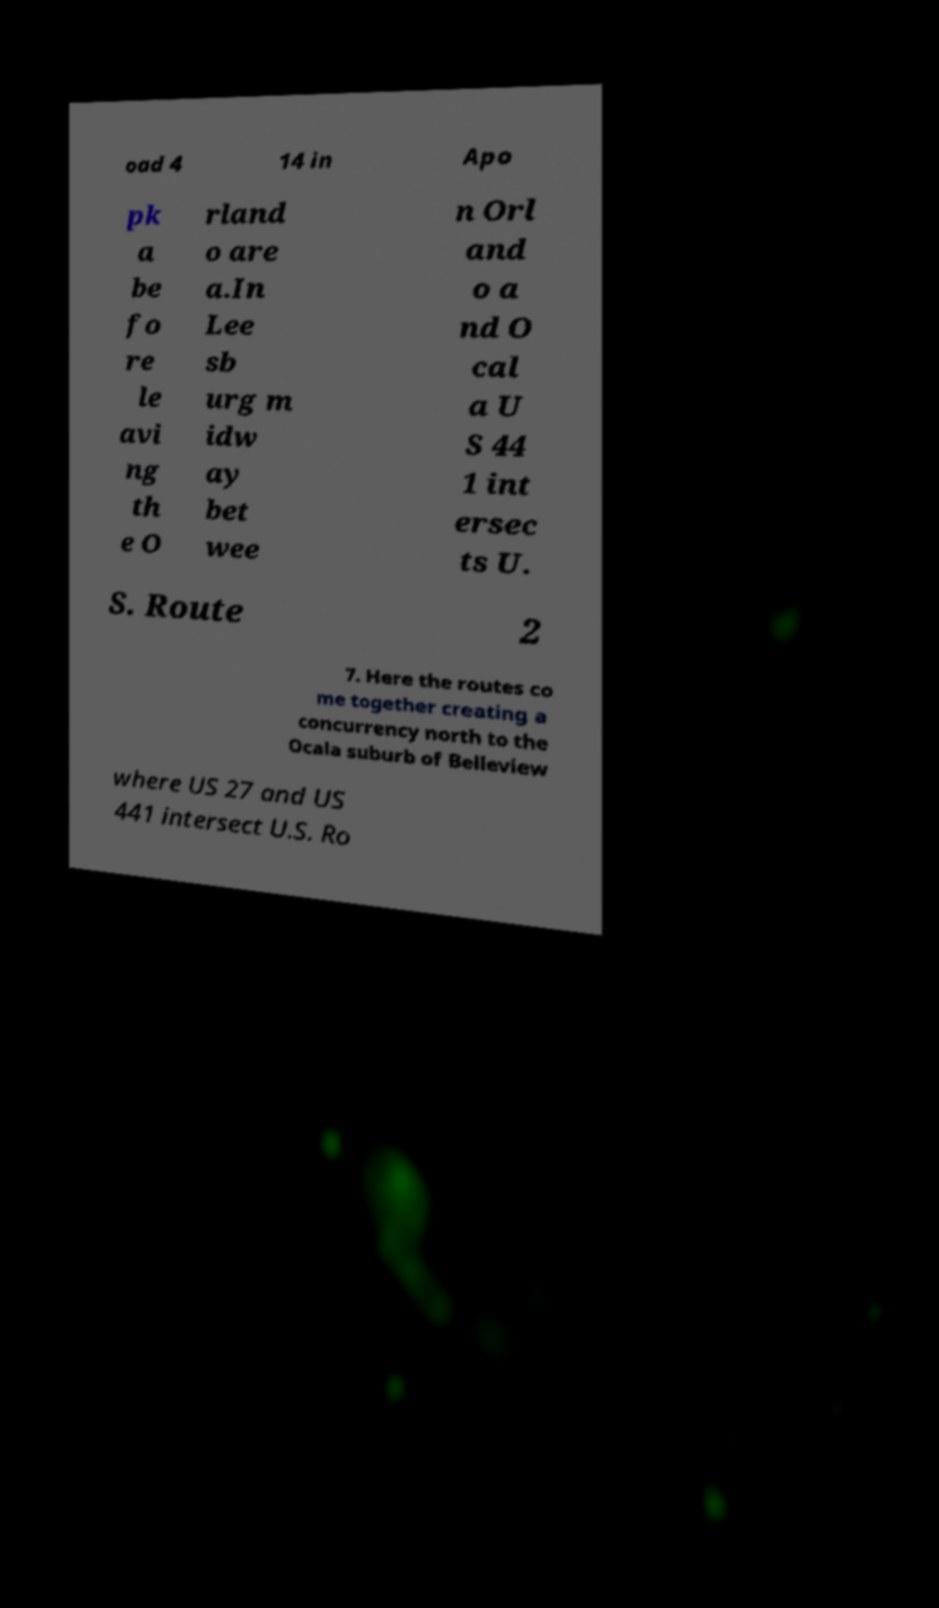Can you read and provide the text displayed in the image?This photo seems to have some interesting text. Can you extract and type it out for me? oad 4 14 in Apo pk a be fo re le avi ng th e O rland o are a.In Lee sb urg m idw ay bet wee n Orl and o a nd O cal a U S 44 1 int ersec ts U. S. Route 2 7. Here the routes co me together creating a concurrency north to the Ocala suburb of Belleview where US 27 and US 441 intersect U.S. Ro 